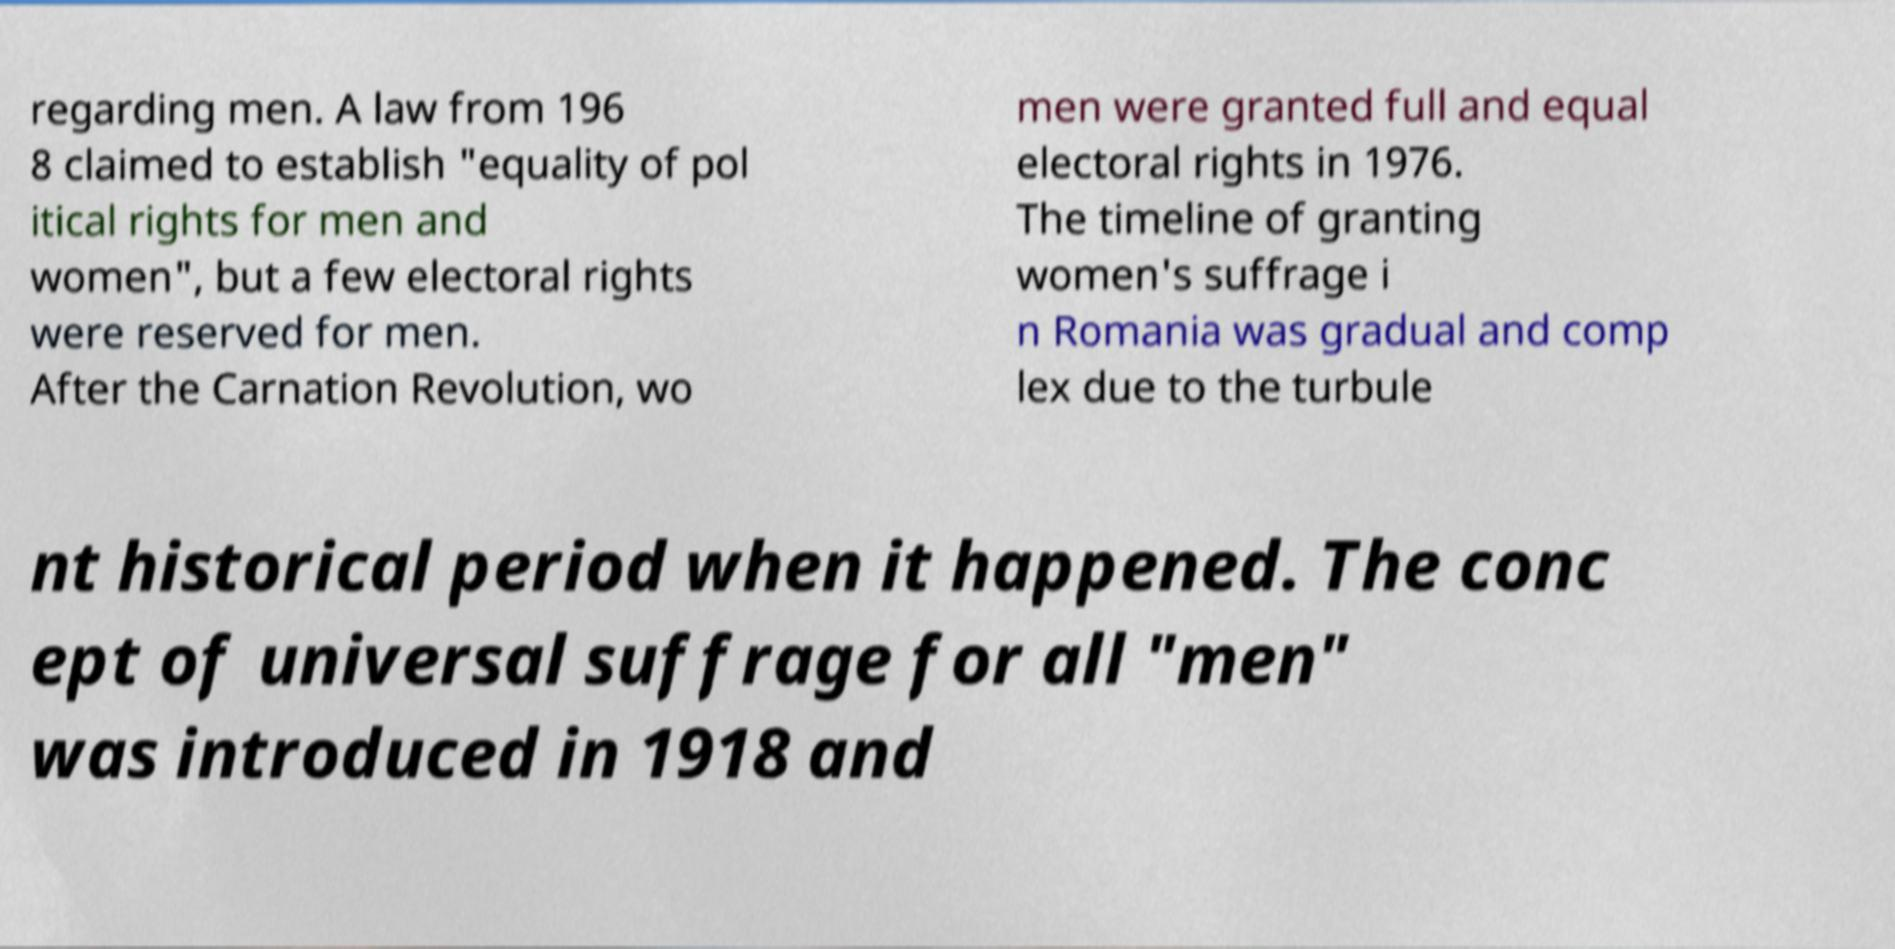Could you extract and type out the text from this image? regarding men. A law from 196 8 claimed to establish "equality of pol itical rights for men and women", but a few electoral rights were reserved for men. After the Carnation Revolution, wo men were granted full and equal electoral rights in 1976. The timeline of granting women's suffrage i n Romania was gradual and comp lex due to the turbule nt historical period when it happened. The conc ept of universal suffrage for all "men" was introduced in 1918 and 